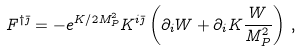<formula> <loc_0><loc_0><loc_500><loc_500>F ^ { \dagger \bar { \jmath } } = - e ^ { K / 2 M _ { P } ^ { 2 } } K ^ { i \bar { \jmath } } \left ( \partial _ { i } W + \partial _ { i } K \frac { W } { M _ { P } ^ { 2 } } \right ) \, ,</formula> 